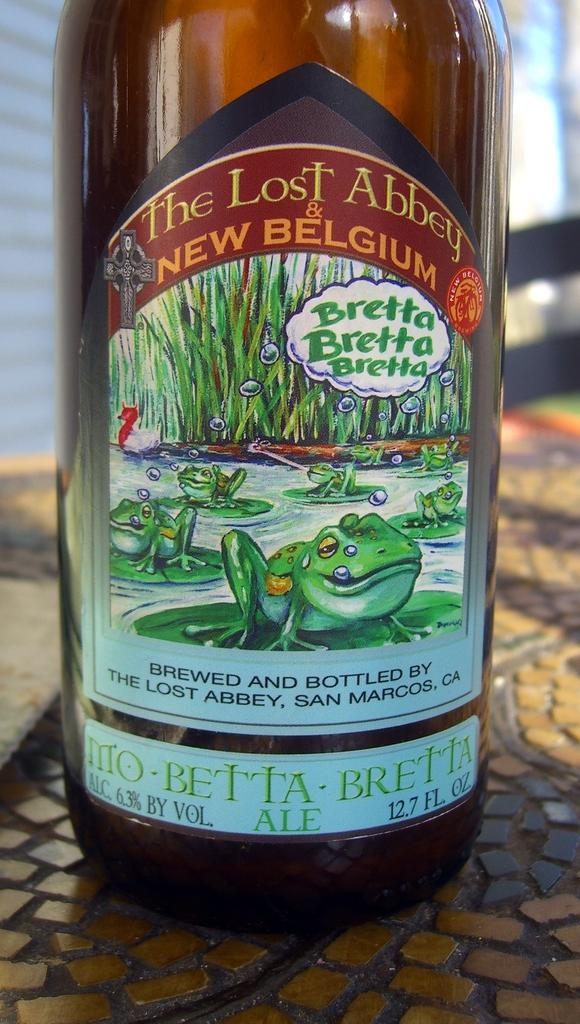<image>
Describe the image concisely. A bottle that states it was brewed and bottled in San Marcos, CA has a frog on the label. 